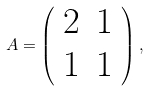Convert formula to latex. <formula><loc_0><loc_0><loc_500><loc_500>A = \left ( \begin{array} { c c } 2 & 1 \\ 1 & 1 \\ \end{array} \right ) ,</formula> 